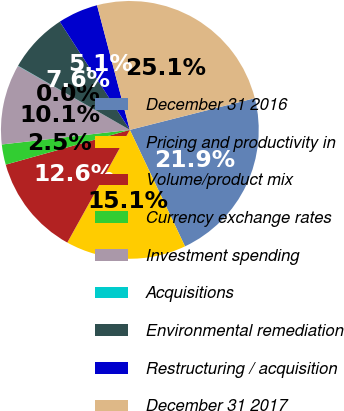Convert chart. <chart><loc_0><loc_0><loc_500><loc_500><pie_chart><fcel>December 31 2016<fcel>Pricing and productivity in<fcel>Volume/product mix<fcel>Currency exchange rates<fcel>Investment spending<fcel>Acquisitions<fcel>Environmental remediation<fcel>Restructuring / acquisition<fcel>December 31 2017<nl><fcel>21.91%<fcel>15.1%<fcel>12.59%<fcel>2.54%<fcel>10.07%<fcel>0.03%<fcel>7.56%<fcel>5.05%<fcel>25.14%<nl></chart> 